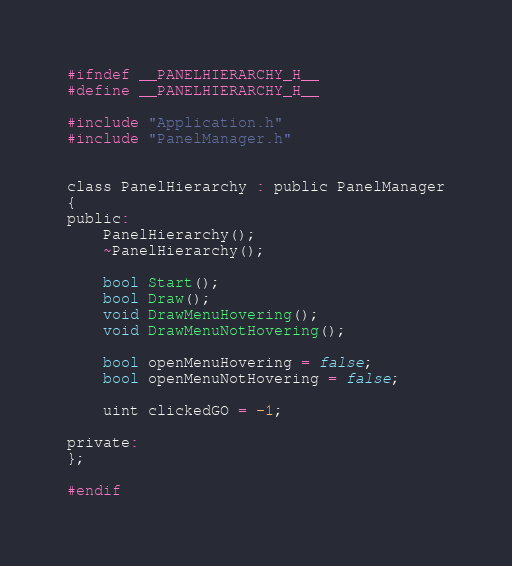Convert code to text. <code><loc_0><loc_0><loc_500><loc_500><_C_>#ifndef __PANELHIERARCHY_H__
#define __PANELHIERARCHY_H__

#include "Application.h"
#include "PanelManager.h"


class PanelHierarchy : public PanelManager
{
public:
	PanelHierarchy();
	~PanelHierarchy();

	bool Start();
	bool Draw();
	void DrawMenuHovering();
	void DrawMenuNotHovering();

	bool openMenuHovering = false;
	bool openMenuNotHovering = false;

	uint clickedGO = -1;

private:
};

#endif
</code> 